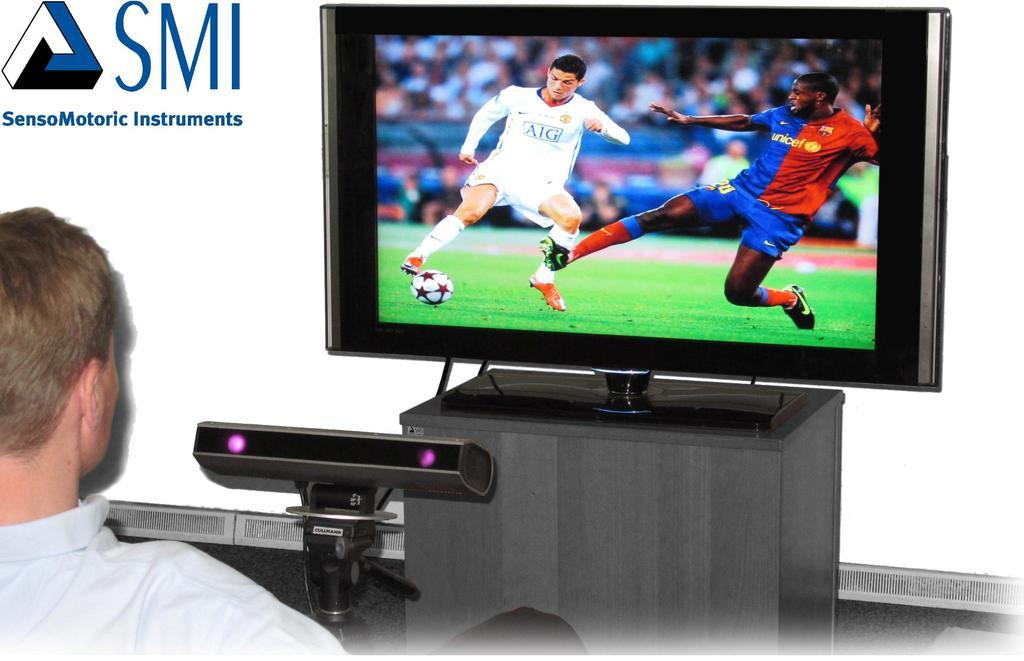Provide a one-sentence caption for the provided image. the letters SMI next to a tv screen. 